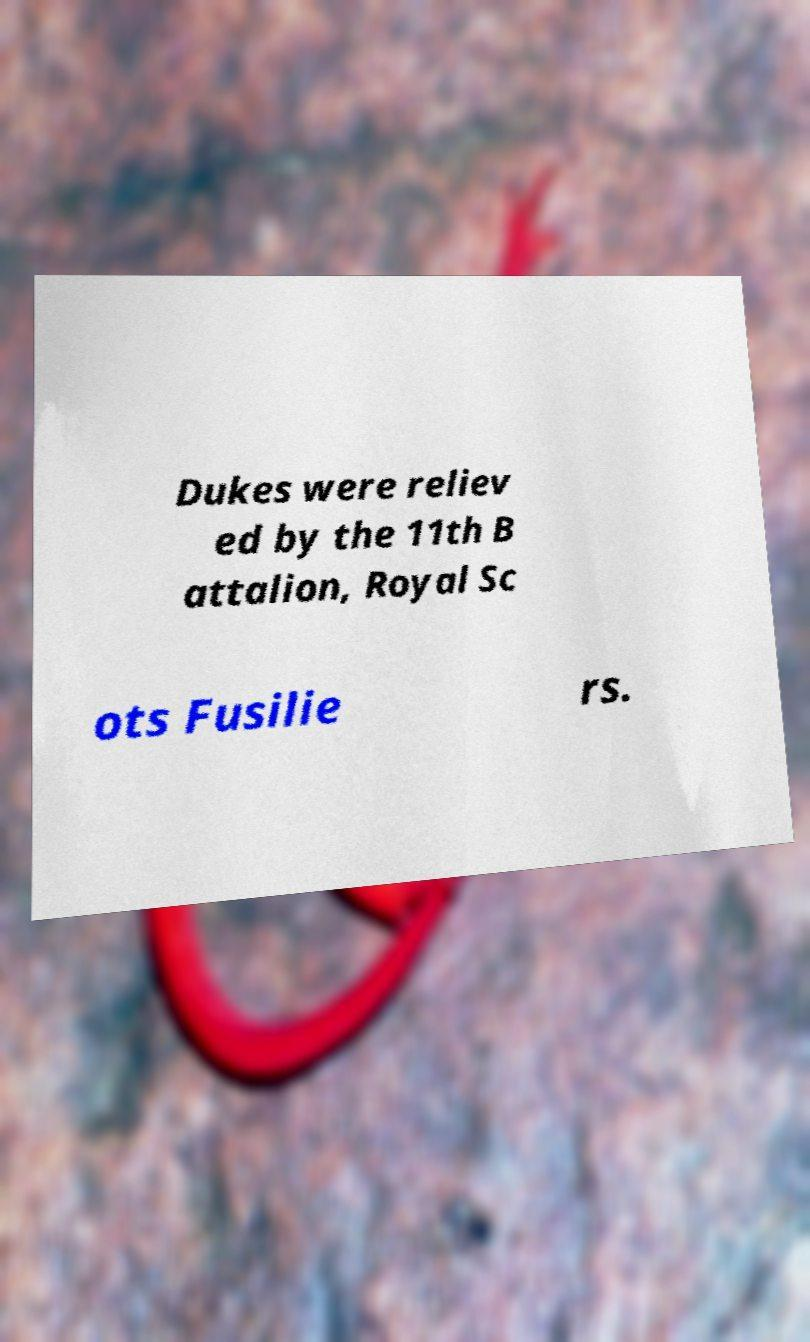I need the written content from this picture converted into text. Can you do that? Dukes were reliev ed by the 11th B attalion, Royal Sc ots Fusilie rs. 